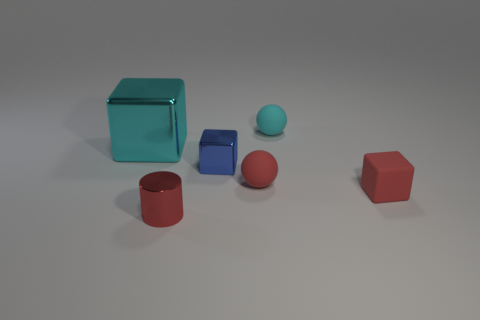How many objects are both to the right of the blue metal thing and on the left side of the small cyan object?
Your answer should be very brief. 1. There is a big cyan metal cube; are there any objects to the right of it?
Ensure brevity in your answer.  Yes. There is a cyan object that is on the right side of the blue thing; does it have the same shape as the red matte thing on the left side of the small cyan object?
Give a very brief answer. Yes. How many things are either purple things or blocks that are in front of the blue shiny thing?
Offer a terse response. 1. How many other objects are there of the same shape as the cyan metallic object?
Keep it short and to the point. 2. Is the large thing to the left of the blue cube made of the same material as the small red sphere?
Keep it short and to the point. No. How many things are either cyan metallic cubes or yellow things?
Your answer should be compact. 1. What is the size of the other metal object that is the same shape as the small blue shiny object?
Offer a very short reply. Large. What size is the red rubber block?
Provide a short and direct response. Small. Are there more blue cubes to the left of the small cyan sphere than tiny gray matte balls?
Make the answer very short. Yes. 